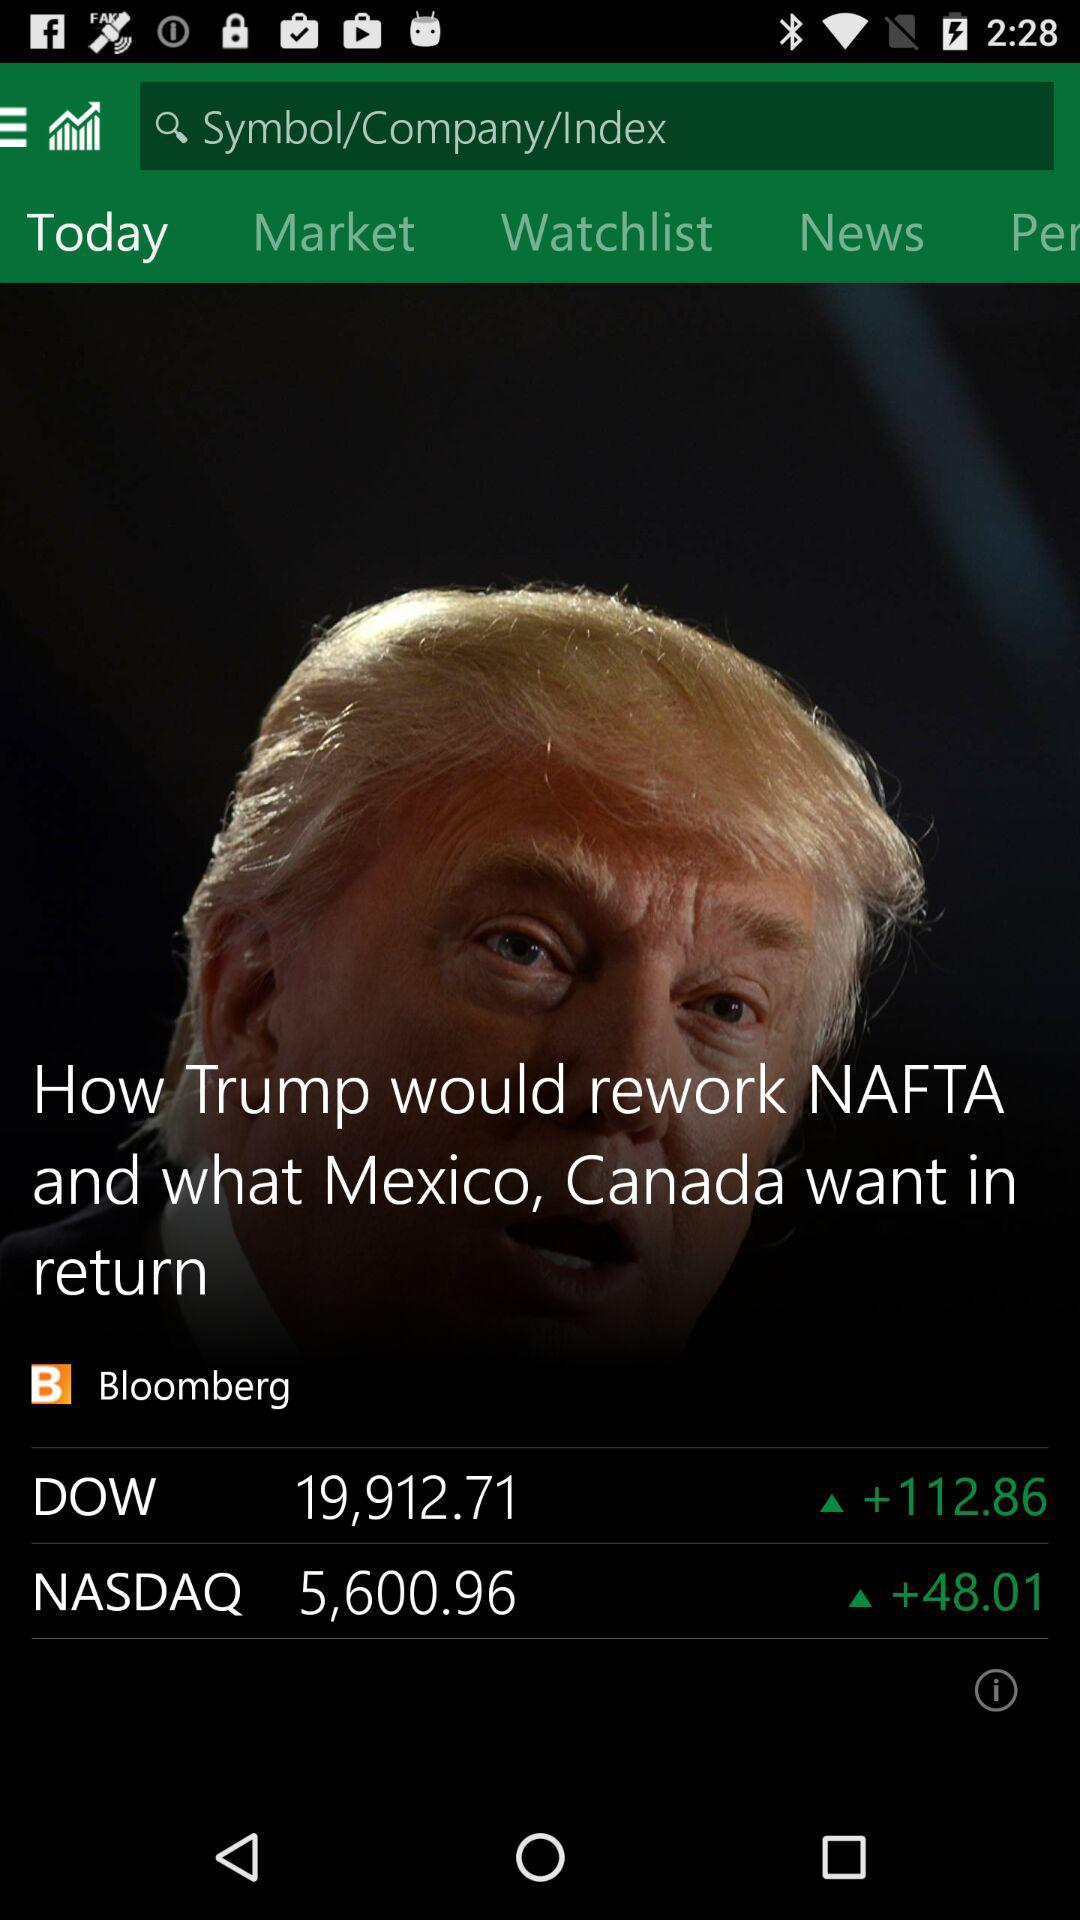How many NASDAQ points are up today?
Answer the question using a single word or phrase. 48.01 